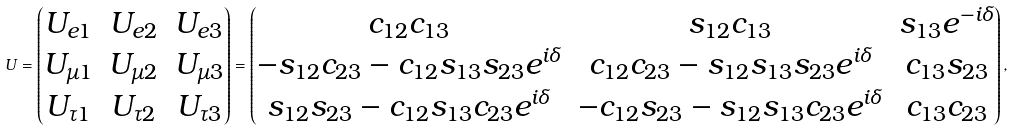Convert formula to latex. <formula><loc_0><loc_0><loc_500><loc_500>U = \begin{pmatrix} U _ { e 1 } & U _ { e 2 } & U _ { e 3 } \\ U _ { \mu 1 } & U _ { \mu 2 } & U _ { \mu 3 } \\ U _ { \tau 1 } & U _ { \tau 2 } & U _ { \tau 3 } \end{pmatrix} = \begin{pmatrix} c _ { 1 2 } c _ { 1 3 } & s _ { 1 2 } c _ { 1 3 } & s _ { 1 3 } e ^ { - i \delta } \\ - s _ { 1 2 } c _ { 2 3 } - c _ { 1 2 } s _ { 1 3 } s _ { 2 3 } e ^ { i \delta } & c _ { 1 2 } c _ { 2 3 } - s _ { 1 2 } s _ { 1 3 } s _ { 2 3 } e ^ { i \delta } & c _ { 1 3 } s _ { 2 3 } \\ s _ { 1 2 } s _ { 2 3 } - c _ { 1 2 } s _ { 1 3 } c _ { 2 3 } e ^ { i \delta } & - c _ { 1 2 } s _ { 2 3 } - s _ { 1 2 } s _ { 1 3 } c _ { 2 3 } e ^ { i \delta } & c _ { 1 3 } c _ { 2 3 } \end{pmatrix} ,</formula> 